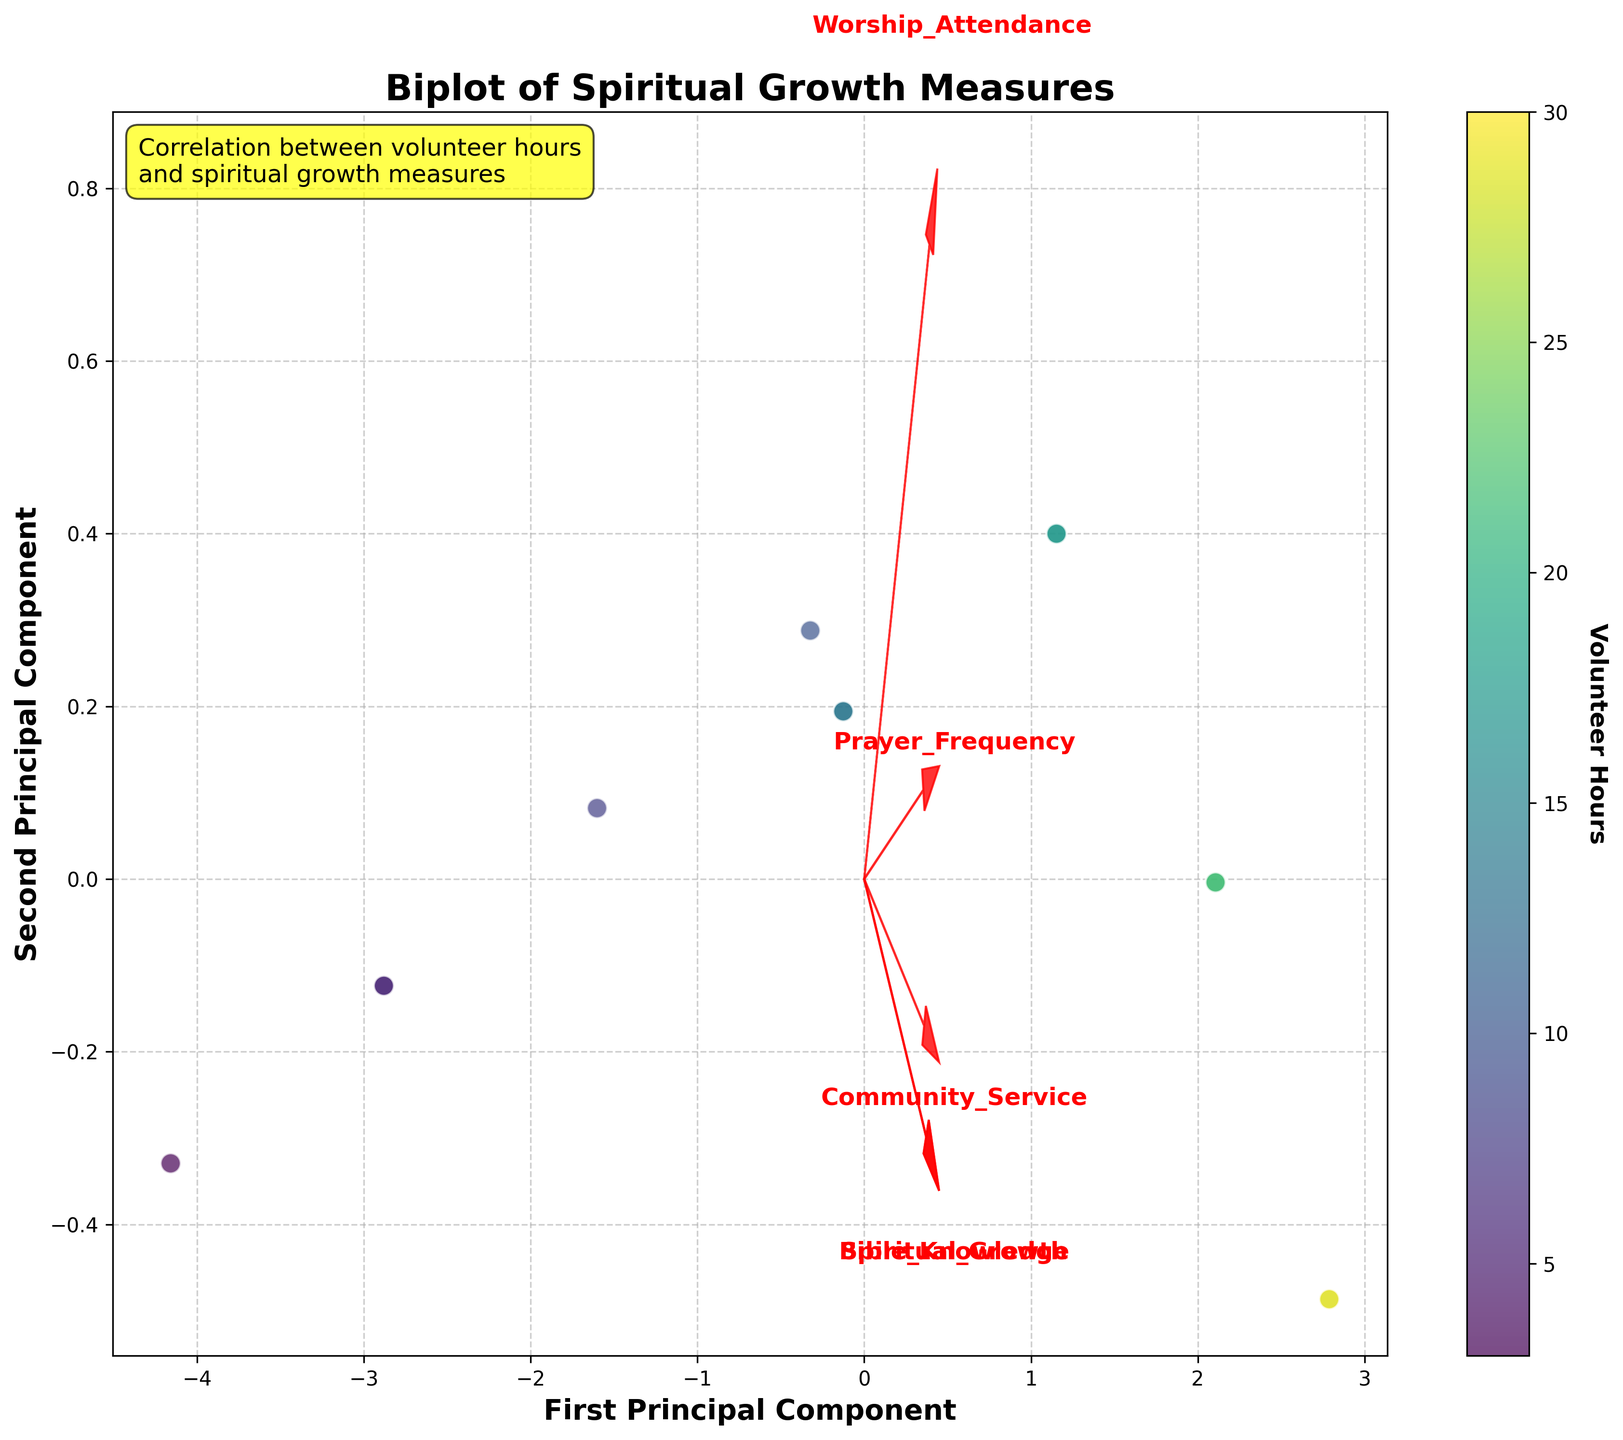What's the title of the plot? The title of the plot is displayed at the top of the figure. By looking at this area, we can see the exact wording used.
Answer: Biplot of Spiritual Growth Measures What do the x and y axes represent in this biplot? The labels of the x and y axes indicate what each represents. The x-axis label is 'First Principal Component' and the y-axis label is 'Second Principal Component'.
Answer: First Principal Component, Second Principal Component How many data points are visualized in the biplot? We count the number of individual points (dots) plotted in the biplot. By doing this, we can determine that there are 13 data points shown.
Answer: 13 What does the color of the data points represent in the biplot? The color bar to the right of the plot indicates what the coloring represents. Here, it corresponds to the 'Volunteer Hours'. This can be inferred from the label on the color bar.
Answer: Volunteer Hours Which spiritual growth measure vector is the longest in the biplot? We examine the lengths of the feature vectors (arrows) plotted from the origin. The longest vector points toward 'Prayer Frequency'.
Answer: Prayer Frequency Which data point might represent the highest volunteer hours based on color? By observing the color bar and the shades, we can identify that the point with the darkest shade (closer to the highest end of the color scale) likely represents the highest volunteer hours. This is the darkest purple point on the plot.
Answer: The darkest purple point Which two spiritual growth measures are most closely aligned in direction in the biplot? We compare the directions of the feature vectors (arrows) from the origin. 'Worship Attendance' and 'Community Service' are very closely aligned.
Answer: Worship Attendance, Community Service Which spiritual growth measure seems least correlated with the first principal component? By reviewing the vectors' alignment with the first principal component axis (x-axis), the vector that is least aligned is 'Bible Knowledge', which is almost orthogonal to the x-axis.
Answer: Bible Knowledge How does the variability in spiritual growth measures relate to volunteer hours? Observing the spread of data points and their color gradient, data points with high volunteer hours (darker colors) tend to cluster where vectors are dense, indicating high spiritual growth measures.
Answer: High volunteer hours correlate with high spiritual growth measures Do higher volunteer hours generally correspond to higher values on the first or second principal component? By examining the direction toward which the data points with higher volunteer hours (darker colors) are clustered, it is evident they are spread out along both components but more so in the first principal component axis.
Answer: First principal component 